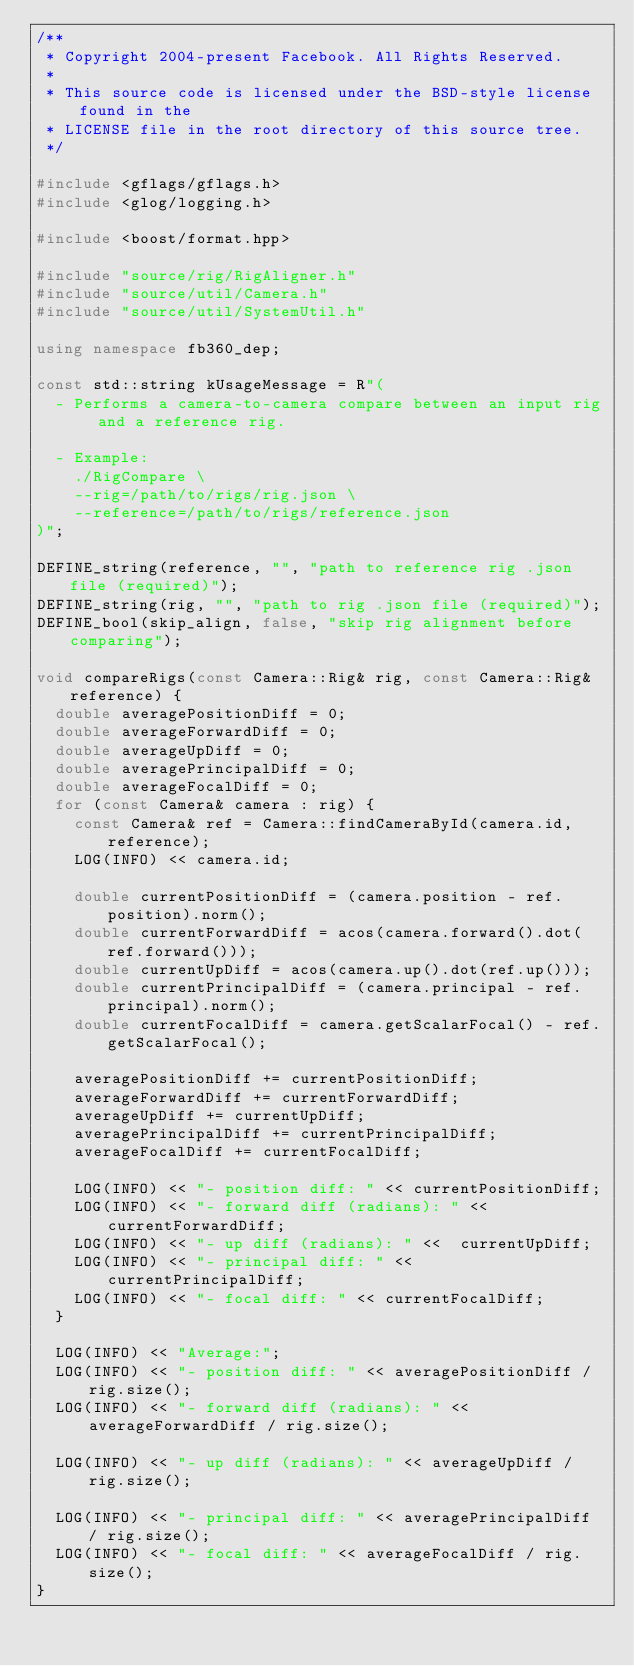Convert code to text. <code><loc_0><loc_0><loc_500><loc_500><_C++_>/**
 * Copyright 2004-present Facebook. All Rights Reserved.
 *
 * This source code is licensed under the BSD-style license found in the
 * LICENSE file in the root directory of this source tree.
 */

#include <gflags/gflags.h>
#include <glog/logging.h>

#include <boost/format.hpp>

#include "source/rig/RigAligner.h"
#include "source/util/Camera.h"
#include "source/util/SystemUtil.h"

using namespace fb360_dep;

const std::string kUsageMessage = R"(
  - Performs a camera-to-camera compare between an input rig and a reference rig.

  - Example:
    ./RigCompare \
    --rig=/path/to/rigs/rig.json \
    --reference=/path/to/rigs/reference.json
)";

DEFINE_string(reference, "", "path to reference rig .json file (required)");
DEFINE_string(rig, "", "path to rig .json file (required)");
DEFINE_bool(skip_align, false, "skip rig alignment before comparing");

void compareRigs(const Camera::Rig& rig, const Camera::Rig& reference) {
  double averagePositionDiff = 0;
  double averageForwardDiff = 0;
  double averageUpDiff = 0;
  double averagePrincipalDiff = 0;
  double averageFocalDiff = 0;
  for (const Camera& camera : rig) {
    const Camera& ref = Camera::findCameraById(camera.id, reference);
    LOG(INFO) << camera.id;

    double currentPositionDiff = (camera.position - ref.position).norm();
    double currentForwardDiff = acos(camera.forward().dot(ref.forward()));
    double currentUpDiff = acos(camera.up().dot(ref.up()));
    double currentPrincipalDiff = (camera.principal - ref.principal).norm();
    double currentFocalDiff = camera.getScalarFocal() - ref.getScalarFocal();

    averagePositionDiff += currentPositionDiff;
    averageForwardDiff += currentForwardDiff;
    averageUpDiff += currentUpDiff;
    averagePrincipalDiff += currentPrincipalDiff;
    averageFocalDiff += currentFocalDiff;

    LOG(INFO) << "- position diff: " << currentPositionDiff;
    LOG(INFO) << "- forward diff (radians): " << currentForwardDiff;
    LOG(INFO) << "- up diff (radians): " <<  currentUpDiff;
    LOG(INFO) << "- principal diff: " <<  currentPrincipalDiff;
    LOG(INFO) << "- focal diff: " << currentFocalDiff;
  }

  LOG(INFO) << "Average:";
  LOG(INFO) << "- position diff: " << averagePositionDiff / rig.size();
  LOG(INFO) << "- forward diff (radians): " <<  averageForwardDiff / rig.size();

  LOG(INFO) << "- up diff (radians): " << averageUpDiff / rig.size();

  LOG(INFO) << "- principal diff: " << averagePrincipalDiff / rig.size();
  LOG(INFO) << "- focal diff: " << averageFocalDiff / rig.size();
}
</code> 